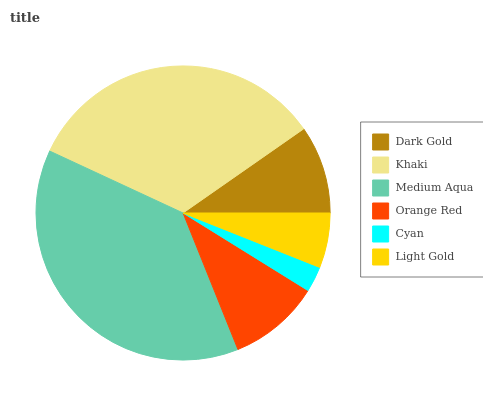Is Cyan the minimum?
Answer yes or no. Yes. Is Medium Aqua the maximum?
Answer yes or no. Yes. Is Khaki the minimum?
Answer yes or no. No. Is Khaki the maximum?
Answer yes or no. No. Is Khaki greater than Dark Gold?
Answer yes or no. Yes. Is Dark Gold less than Khaki?
Answer yes or no. Yes. Is Dark Gold greater than Khaki?
Answer yes or no. No. Is Khaki less than Dark Gold?
Answer yes or no. No. Is Orange Red the high median?
Answer yes or no. Yes. Is Dark Gold the low median?
Answer yes or no. Yes. Is Light Gold the high median?
Answer yes or no. No. Is Light Gold the low median?
Answer yes or no. No. 